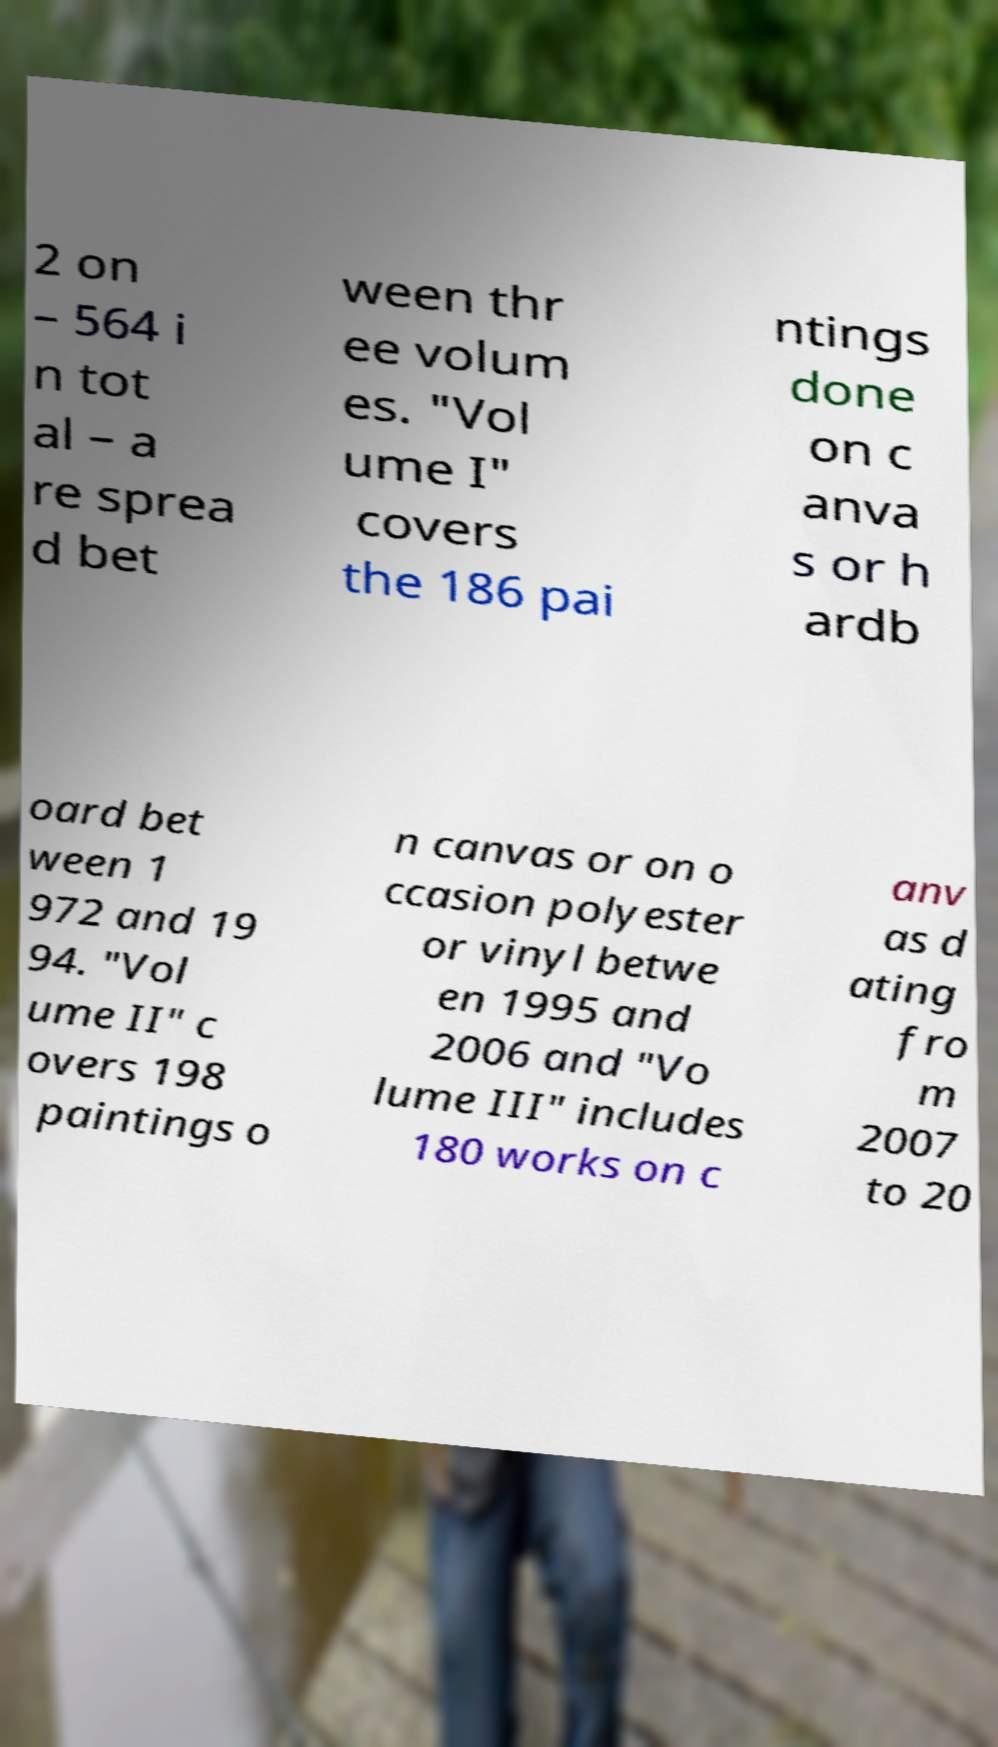Can you read and provide the text displayed in the image?This photo seems to have some interesting text. Can you extract and type it out for me? 2 on – 564 i n tot al – a re sprea d bet ween thr ee volum es. "Vol ume I" covers the 186 pai ntings done on c anva s or h ardb oard bet ween 1 972 and 19 94. "Vol ume II" c overs 198 paintings o n canvas or on o ccasion polyester or vinyl betwe en 1995 and 2006 and "Vo lume III" includes 180 works on c anv as d ating fro m 2007 to 20 